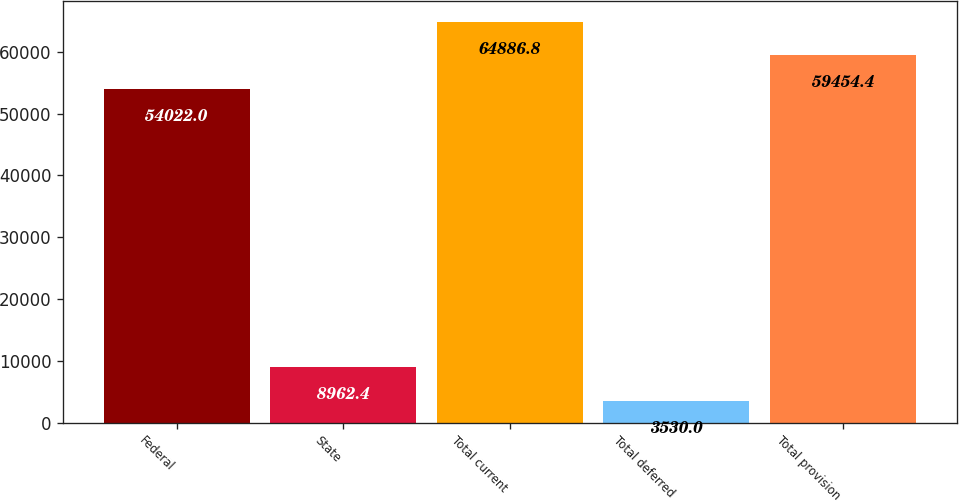Convert chart. <chart><loc_0><loc_0><loc_500><loc_500><bar_chart><fcel>Federal<fcel>State<fcel>Total current<fcel>Total deferred<fcel>Total provision<nl><fcel>54022<fcel>8962.4<fcel>64886.8<fcel>3530<fcel>59454.4<nl></chart> 